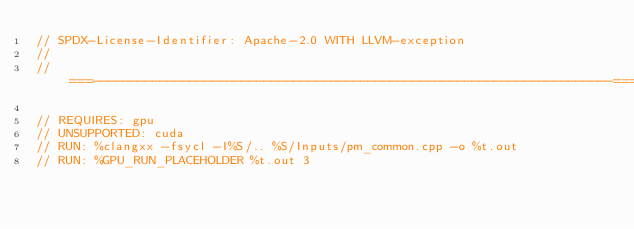Convert code to text. <code><loc_0><loc_0><loc_500><loc_500><_C++_>// SPDX-License-Identifier: Apache-2.0 WITH LLVM-exception
//
//===----------------------------------------------------------------------===//

// REQUIRES: gpu
// UNSUPPORTED: cuda
// RUN: %clangxx -fsycl -I%S/.. %S/Inputs/pm_common.cpp -o %t.out
// RUN: %GPU_RUN_PLACEHOLDER %t.out 3
</code> 